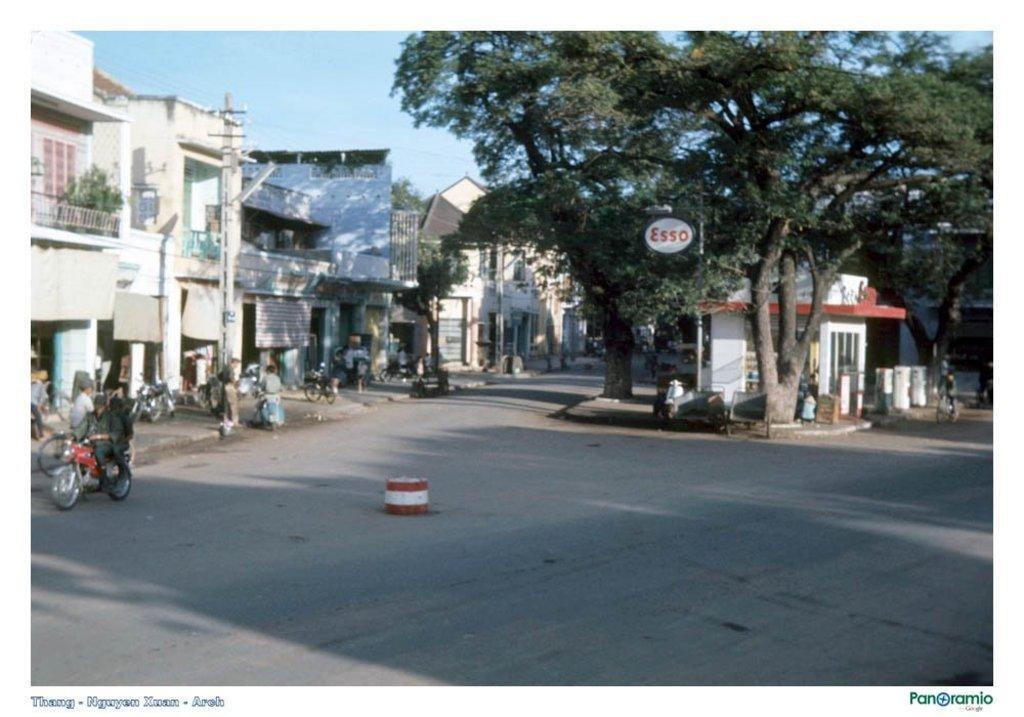Describe this image in one or two sentences. In this image, we can see vehicles and people on the road. In the background, there are buildings, trees, poles and we can see some plants. At the top, there is sky. At the bottom, there is some text. 